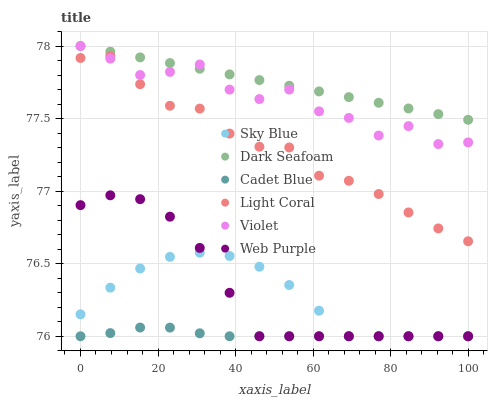Does Cadet Blue have the minimum area under the curve?
Answer yes or no. Yes. Does Dark Seafoam have the maximum area under the curve?
Answer yes or no. Yes. Does Web Purple have the minimum area under the curve?
Answer yes or no. No. Does Web Purple have the maximum area under the curve?
Answer yes or no. No. Is Dark Seafoam the smoothest?
Answer yes or no. Yes. Is Violet the roughest?
Answer yes or no. Yes. Is Web Purple the smoothest?
Answer yes or no. No. Is Web Purple the roughest?
Answer yes or no. No. Does Cadet Blue have the lowest value?
Answer yes or no. Yes. Does Light Coral have the lowest value?
Answer yes or no. No. Does Violet have the highest value?
Answer yes or no. Yes. Does Web Purple have the highest value?
Answer yes or no. No. Is Sky Blue less than Light Coral?
Answer yes or no. Yes. Is Dark Seafoam greater than Web Purple?
Answer yes or no. Yes. Does Cadet Blue intersect Web Purple?
Answer yes or no. Yes. Is Cadet Blue less than Web Purple?
Answer yes or no. No. Is Cadet Blue greater than Web Purple?
Answer yes or no. No. Does Sky Blue intersect Light Coral?
Answer yes or no. No. 